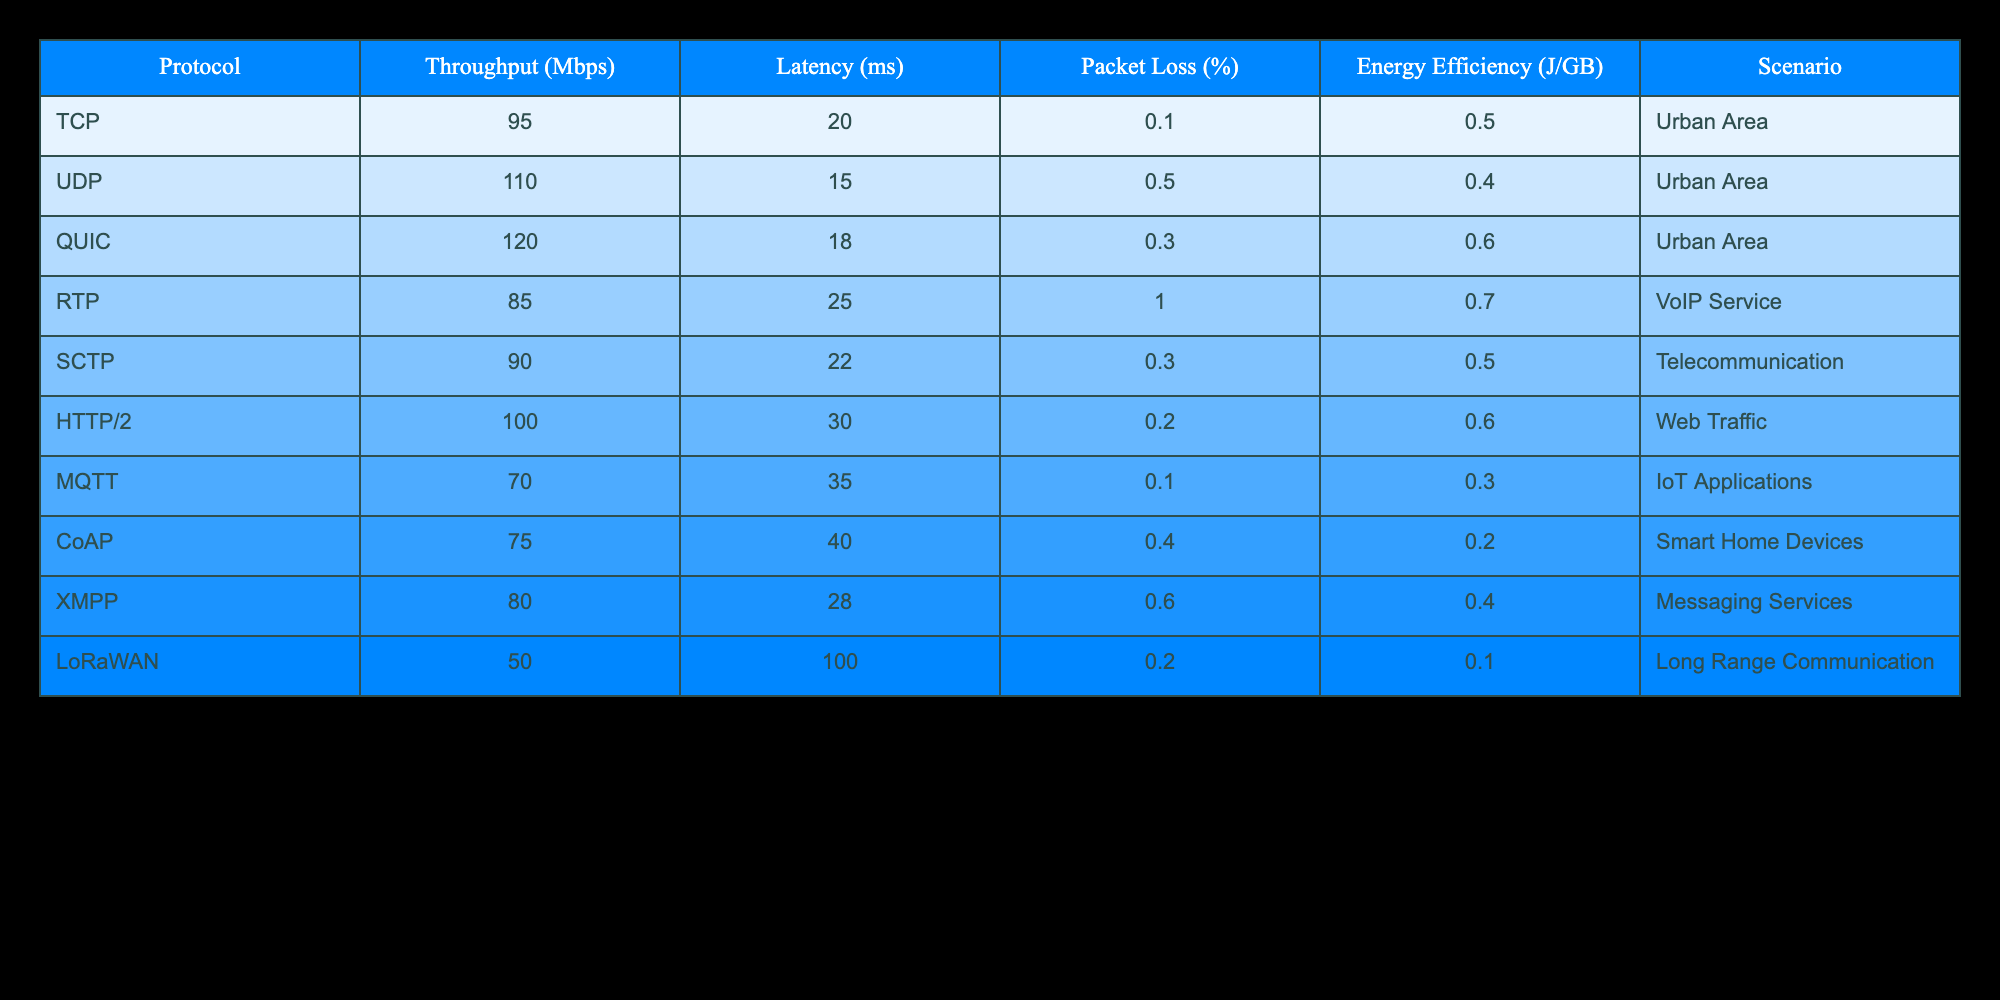What is the throughput of the QUIC protocol? The value for the QUIC protocol is directly presented in the table under the "Throughput (Mbps)" column. It shows 120 Mbps as the throughput for QUIC.
Answer: 120 Mbps Which protocol has the highest energy efficiency? By looking at the "Energy Efficiency (J/GB)" column, we can see that the QUIC protocol has an energy efficiency value of 0.6, which is higher than all others listed.
Answer: QUIC How many protocols have a packet loss percentage greater than 0.5%? The "Packet Loss (%)" column indicates that two protocols, UDP (0.5%) and RTP (1.0%) have values greater than 0.5%. Thus, there are two protocols meeting this criterion.
Answer: 2 What is the average latency of all protocols? To calculate the average latency, we first sum all the latency values: 20 + 15 + 18 + 25 + 22 + 30 + 35 + 40 + 28 + 100 =  313. There are 10 protocols, so the average is 313 / 10 = 31.3 ms.
Answer: 31.3 ms Is it true that TCP has a higher throughput than HTTP/2? We can see from the "Throughput (Mbps)" column that TCP has a throughput of 95 Mbps and HTTP/2 has 100 Mbps, confirming that TCP does not exceed HTTP/2 in throughput.
Answer: No Which protocol has the lowest latency in the Urban Area scenario? The table specifies the latency for UDP at 15 ms as the lowest in the Urban Area scenario compared to others listed for that scenario.
Answer: UDP What is the difference in throughput between the best and the worst-performing protocol? The highest throughput is seen for QUIC at 120 Mbps and the lowest is for LoRaWAN at 50 Mbps. To find the difference, we subtract: 120 - 50 = 70 Mbps.
Answer: 70 Mbps Which protocol has the highest packet loss percentage among those used for VoIP Service? Checking the "Packet Loss (%)" for RTP (1.0%) shows it has the highest packet loss in that specific scenario, as it is the only one in the VoIP Service category.
Answer: RTP Which protocol is the most energy-efficient for IoT applications? From the "Energy Efficiency (J/GB)" column for the given scenario, we find that MQTT has an energy efficiency of 0.3 J/GB, which is more efficient than the CoAP. Therefore, for IoT applications, MQTT is the most energy-efficient.
Answer: MQTT 